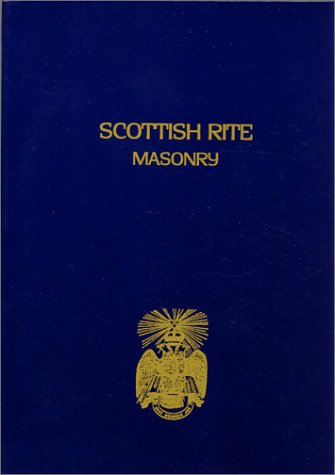Can you explain what the Scottish Rite is? The Scottish Rite is a branch of Freemasonry that expands upon the standard three degrees of Blue Lodge Masonry to include additional degrees, often from the 4th to the 33rd, offering a more detailed exploration of Masonic symbolism and philosophy. 